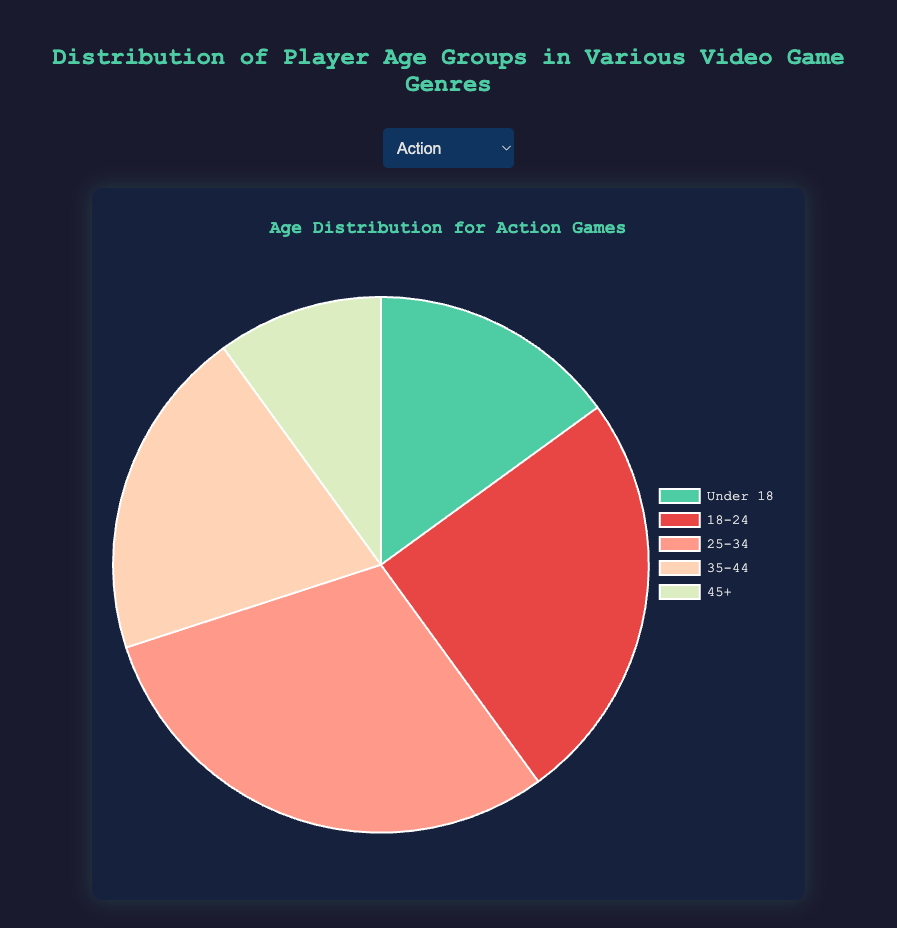What is the percentage of players aged 18-24 in the Action genre? Look at the slice of the pie chart representing the 18-24 age group for the Action genre and note the value. There are 5 age groups in total and 25 for the 18-24 age group. Sum all values: 15 + 25 + 30 + 20 + 10 = 100. Calculate the percentage for 18-24: (25 / 100) * 100 = 25%.
Answer: 25% In which genre is the percentage of players aged 35-44 the highest? Compare the size of the pie slices representing the 35-44 age group for all genres. Puzzle has the 35-44 age group slice the largest at 30 out of a total of 100 as the highest percentage ( 30%)
Answer: Puzzle What is the average number of players aged 25-34 across all genres? For each genre, sum the number of players aged 25-34: (30 + 35 + 25 + 25 + 30 + 20 + 25 + 30 + 35) = 255. There are 9 genres, so the average is 255 / 9 ≈ 28.33
Answer: 28.33 Which age group has the smallest proportion in the Simulation genre? Look at the smallest slice of the pie chart for the Simulation genre. The "Under 18" group has 10 players, the least proportion.
Answer: Under 18 What's the difference in the number of players aged 45+ between Strategy and Puzzle genres? Note the number of players aged 45+ in Strategy (25) and Puzzle (35). Calculate the difference: 35 - 25 = 10.
Answer: 10 Which genre has the highest proportion of players aged under 18? Compare the size of the pie slices representing the "Under 18" age group for all genres. Sports and Casual have the largest slices with 20 players each out of 100, so 20% for each.
Answer: Sports, Casual What is the sum of players aged 35-44 in Adventure and Horror genres? Note the number of players aged 35-44 in Adventure (20) and Horror (25). Calculate the sum: 20 + 25 = 45.
Answer: 45 What is the ratio of players aged 18-24 to those aged 25-34 in the Role-Playing genre? Note the number of players aged 18-24 (20) and aged 25-34 (35) in the Role-Playing genre. Calculate the ratio: 20 / 35 = 0.57.
Answer: 0.57 